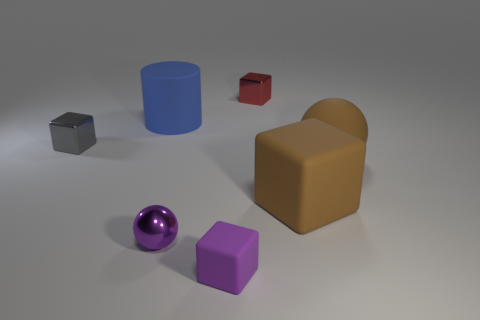Is there a pattern or theme in the arrangement of the objects? The objects appear to be arranged randomly with no discernible pattern, representing a variety of geometric shapes, colors, and textures which give the scene a diverse and contrasting appearance. 